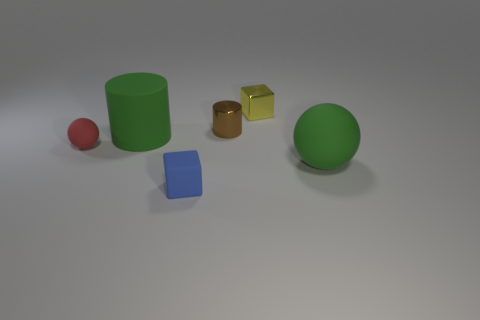Add 1 green matte cylinders. How many objects exist? 7 Subtract all cubes. How many objects are left? 4 Add 3 yellow blocks. How many yellow blocks exist? 4 Subtract 0 brown spheres. How many objects are left? 6 Subtract all tiny gray metal cylinders. Subtract all rubber things. How many objects are left? 2 Add 2 tiny metal cylinders. How many tiny metal cylinders are left? 3 